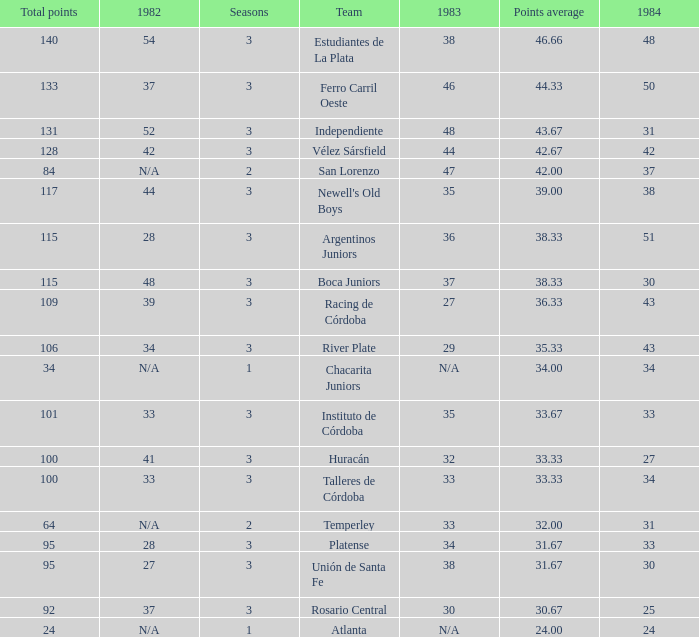What team had 3 seasons and fewer than 27 in 1984? Rosario Central. 